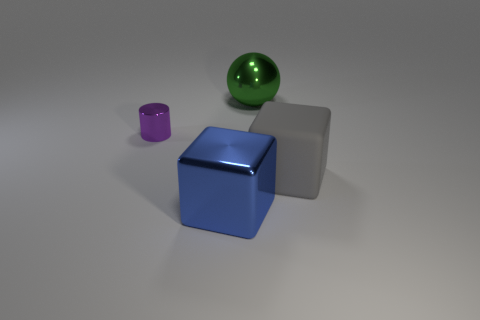Are there any other things that are the same material as the gray object?
Your response must be concise. No. Do the large cube on the left side of the large rubber block and the large thing behind the large rubber thing have the same color?
Your answer should be compact. No. How many other objects are there of the same shape as the matte object?
Provide a succinct answer. 1. Are there the same number of blue things that are behind the blue object and large objects in front of the green metal object?
Keep it short and to the point. No. Is the large cube left of the big green sphere made of the same material as the object behind the tiny purple metallic cylinder?
Provide a succinct answer. Yes. What number of other things are there of the same size as the metallic block?
Make the answer very short. 2. How many things are either small brown matte cylinders or blocks to the left of the big metallic sphere?
Your response must be concise. 1. Are there the same number of large shiny objects left of the small purple cylinder and tiny matte cylinders?
Your answer should be very brief. Yes. The large blue object that is made of the same material as the large green object is what shape?
Provide a short and direct response. Cube. How many shiny things are tiny purple objects or gray cubes?
Provide a succinct answer. 1. 